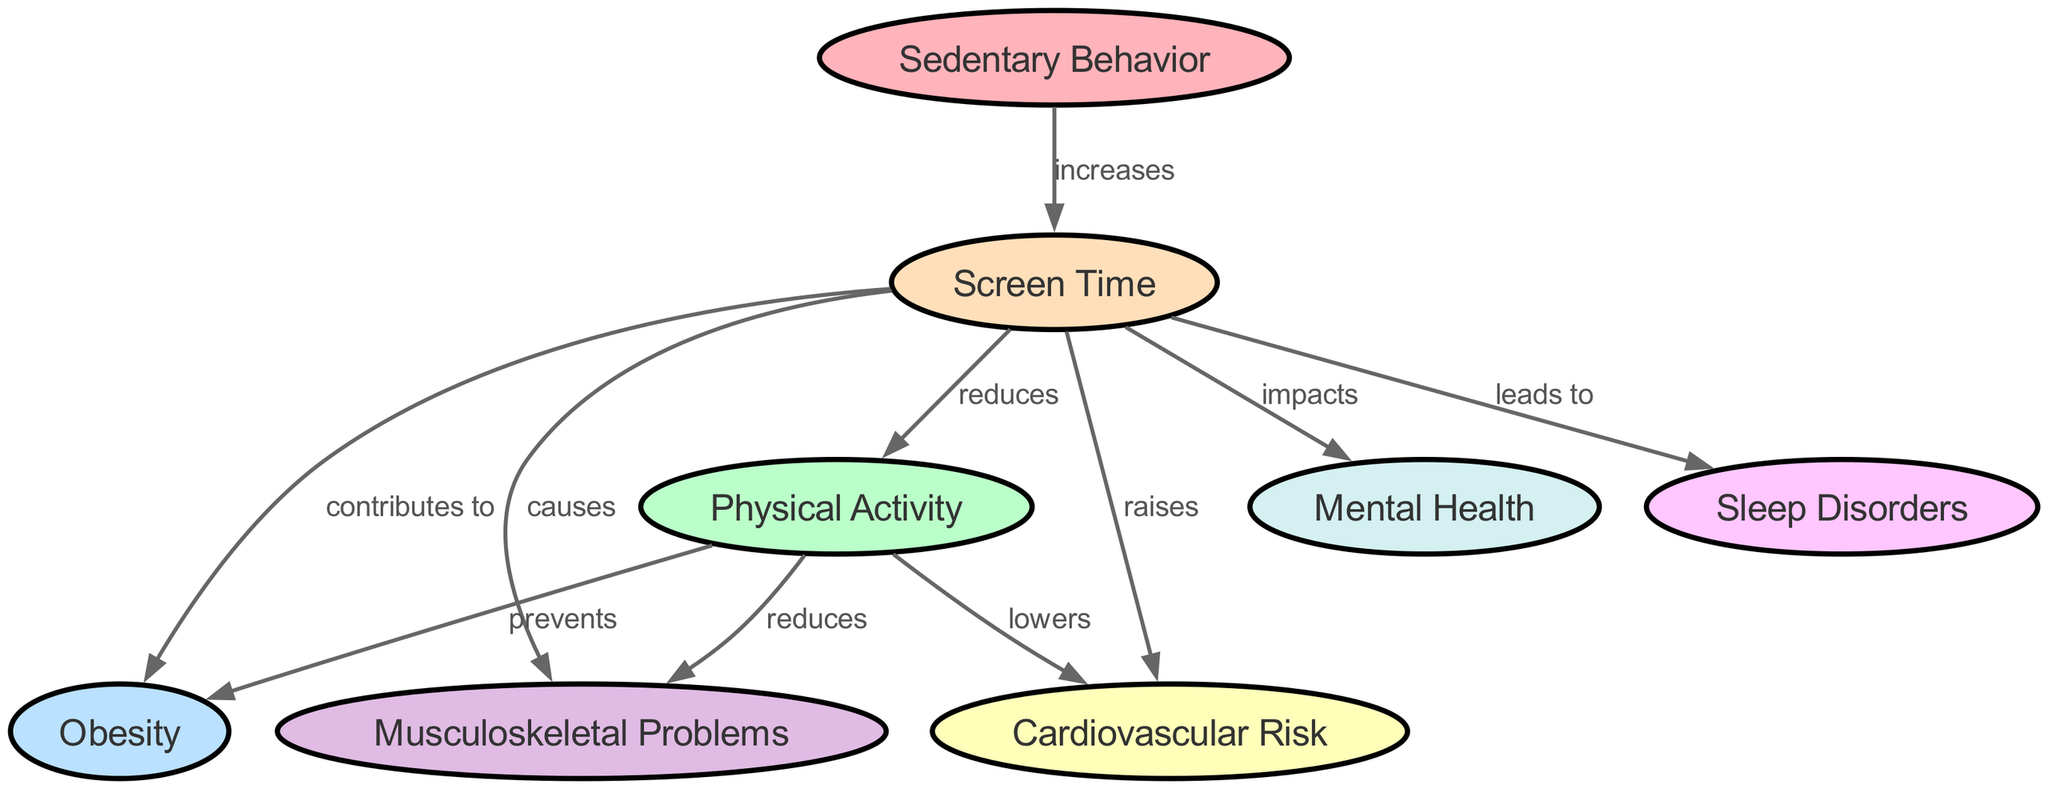What is the total number of nodes in the diagram? The diagram lists 8 nodes, which are Sedentary Behavior, Screen Time, Physical Activity, Obesity, Cardiovascular Risk, Musculoskeletal Problems, Mental Health, and Sleep Disorders.
Answer: 8 Which behavior increases Screen Time? According to the diagram, Sedentary Behavior is the factor that increases Screen Time.
Answer: Sedentary Behavior What impact does Screen Time have on Physical Activity? The diagram shows that Screen Time reduces Physical Activity, as indicated by the directed edge from Screen Time to Physical Activity.
Answer: Reduces How many impacts does Screen Time have on health-related issues? Analyzing the edges emanating from Screen Time, there are a total of four health-related issues that it impacts: Obesity, Cardiovascular Risk, Musculoskeletal Problems, and Mental Health, as per the diagram.
Answer: 4 What effect does Physical Activity have on Obesity? The diagram indicates that Physical Activity prevents Obesity, represented by the directed edge from Physical Activity to Obesity.
Answer: Prevents What are the consequences of increased Screen Time in relation to Sleep Disorders? The diagram states that increased Screen Time leads to Sleep Disorders, highlighting a direct causal relationship as illustrated by the edge from Screen Time to Sleep Disorders.
Answer: Leads to What is the relationship between Physical Activity and Musculoskeletal Problems? Per the diagram, the relationship shows that Physical Activity reduces Musculoskeletal Problems, with a directed edge illustrating this effect.
Answer: Reduces What type of health issue does Screen Time contribute to? The diagram specifies that Screen Time contributes to Obesity, highlighting one of its significant negative effects on health.
Answer: Obesity How does Physical Activity affect Cardiovascular Risk? According to the diagram, Physical Activity lowers the risk of Cardiovascular issues, demonstrated by the edge leading from Physical Activity to Cardiovascular Risk.
Answer: Lowers 